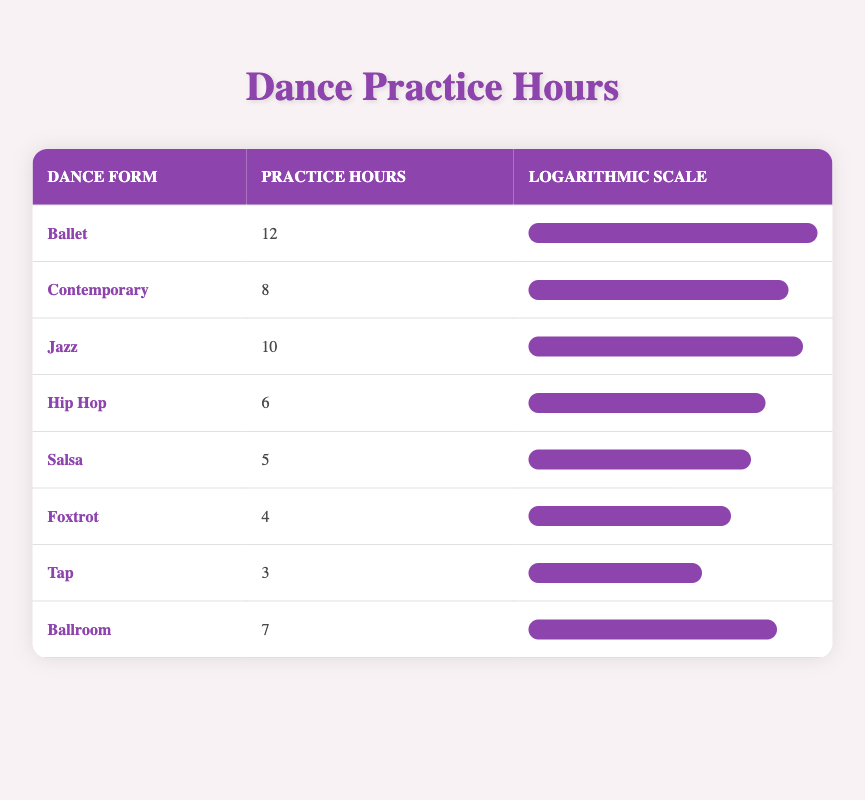What is the practice hour for Ballet? The table directly lists the practice hours for Ballet, and it states that the practice hours are 12.
Answer: 12 Which dance form has the least practice hours? Looking at the practice hours in the table, Salsa has the least with 5 hours, followed by Foxtrot with 4 hours, and Tap with 3 hours. However, Tap is the one with the absolute least.
Answer: 3 What is the total practice hours for Jazz and Contemporary combined? From the table, Jazz has 10 hours and Contemporary has 8 hours. Adding these two values together, 10 + 8 equals 18.
Answer: 18 Is the practice hour for Foxtrot greater than or equal to 5? The table shows that Foxtrot has 4 practice hours. Since 4 is less than 5, this statement is false.
Answer: No What is the average number of practice hours across all dance forms listed? To find the average, we need to sum the practice hours (12 + 8 + 10 + 6 + 5 + 4 + 3 + 7 = 55) and divide by the number of dance forms (which is 8). Therefore, 55 divided by 8 equals 6.875.
Answer: 6.875 Which dance form has practice hours closest to Foxtrot? Foxtrot has 4 practice hours, and the closest values in the table are Tap with 3 hours and Salsa with 5 hours. Since 4 is closer to 5 than to 3, Salsa is the closest to Foxtrot.
Answer: Salsa How many more hours of practice does Ballet have compared to Foxtrot? Ballet has 12 hours and Foxtrot has 4 hours. To find the difference, subtract Foxtrot’s hours from Ballet’s hours (12 - 4 = 8).
Answer: 8 Which dance forms have more practice hours than Ballroom? The table shows that Ballroom has 7 hours of practice. Ballet (12), Jazz (10), and Contemporary (8) have more hours than Ballroom.
Answer: Ballet, Jazz, Contemporary 